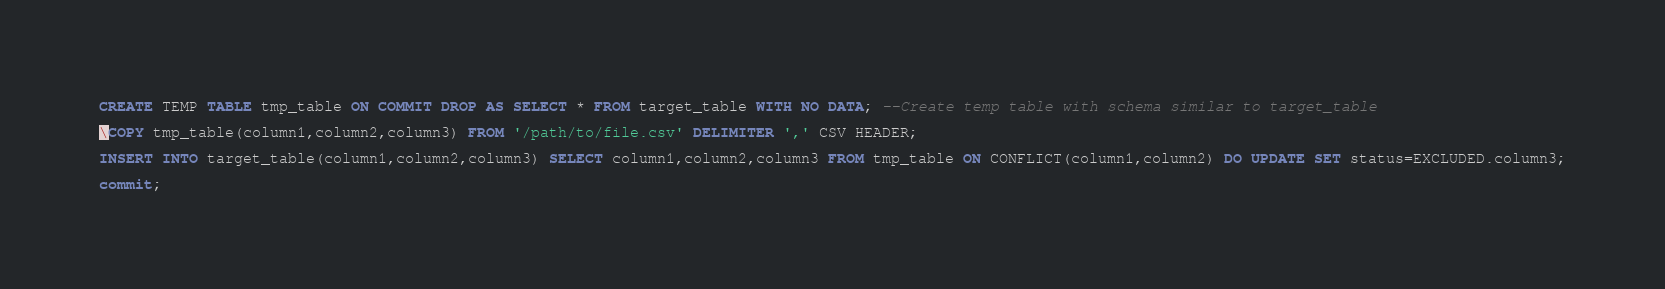Convert code to text. <code><loc_0><loc_0><loc_500><loc_500><_SQL_>CREATE TEMP TABLE tmp_table ON COMMIT DROP AS SELECT * FROM target_table WITH NO DATA; --Create temp table with schema similar to target_table

\COPY tmp_table(column1,column2,column3) FROM '/path/to/file.csv' DELIMITER ',' CSV HEADER; 

INSERT INTO target_table(column1,column2,column3) SELECT column1,column2,column3 FROM tmp_table ON CONFLICT(column1,column2) DO UPDATE SET status=EXCLUDED.column3;

commit;</code> 